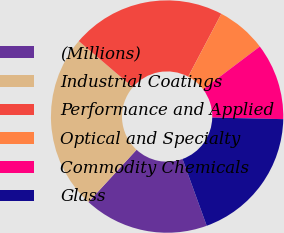Convert chart to OTSL. <chart><loc_0><loc_0><loc_500><loc_500><pie_chart><fcel>(Millions)<fcel>Industrial Coatings<fcel>Performance and Applied<fcel>Optical and Specialty<fcel>Commodity Chemicals<fcel>Glass<nl><fcel>17.37%<fcel>24.42%<fcel>21.47%<fcel>6.98%<fcel>10.65%<fcel>19.11%<nl></chart> 